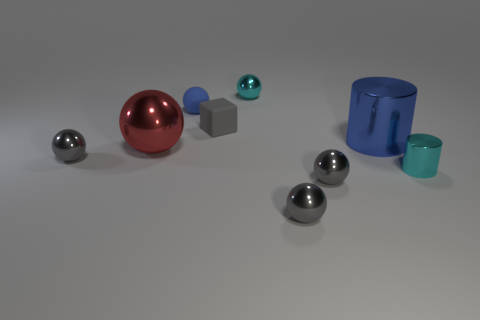There is a blue shiny thing that is the same size as the red shiny thing; what shape is it?
Provide a short and direct response. Cylinder. What number of objects are either cyan things or small gray metallic things on the left side of the blue sphere?
Offer a very short reply. 3. There is a tiny cyan object that is behind the small metal thing that is to the left of the small cube; what number of gray things are on the left side of it?
Your response must be concise. 2. What is the color of the small cylinder that is the same material as the big cylinder?
Your answer should be very brief. Cyan. Do the metal sphere on the left side of the red thing and the blue matte thing have the same size?
Provide a succinct answer. Yes. What number of objects are either small brown balls or tiny cyan metal objects?
Give a very brief answer. 2. What material is the cyan thing in front of the gray object that is behind the tiny metal ball on the left side of the cyan metal sphere?
Give a very brief answer. Metal. What material is the small object that is to the left of the small blue ball?
Offer a terse response. Metal. Is there a purple thing that has the same size as the gray rubber block?
Offer a very short reply. No. Do the shiny object that is on the left side of the large sphere and the tiny shiny cylinder have the same color?
Give a very brief answer. No. 